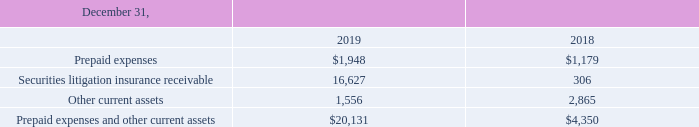Note 7. Prepaid Expenses and Other Current Assets and Accrued and Other Current Liabilities
Prepaid expenses and other current assets as of December 31, 2019 and 2018 consisted of the following:
What are the respective prepaid expenses in 2018 and 2019? $1,179, $1,948. What are the respective securities litigation insurance receivable in 2018 and 2019? 306, 16,627. What are the respective other current assets in 2018 and 2019?  2,865, 1,556. What is the percentage change in prepaid expenses between 2018 and 2019?
Answer scale should be: percent. (1,948 - 1,179)/1,179 
Answer: 65.22. What is the average prepaid expenses paid in 2018 and 2019? (1,948 + 1,179)/2 
Answer: 1563.5. What is the total prepaid expenses made in 2018 and 2019? 1,948 + 1,179 
Answer: 3127. 